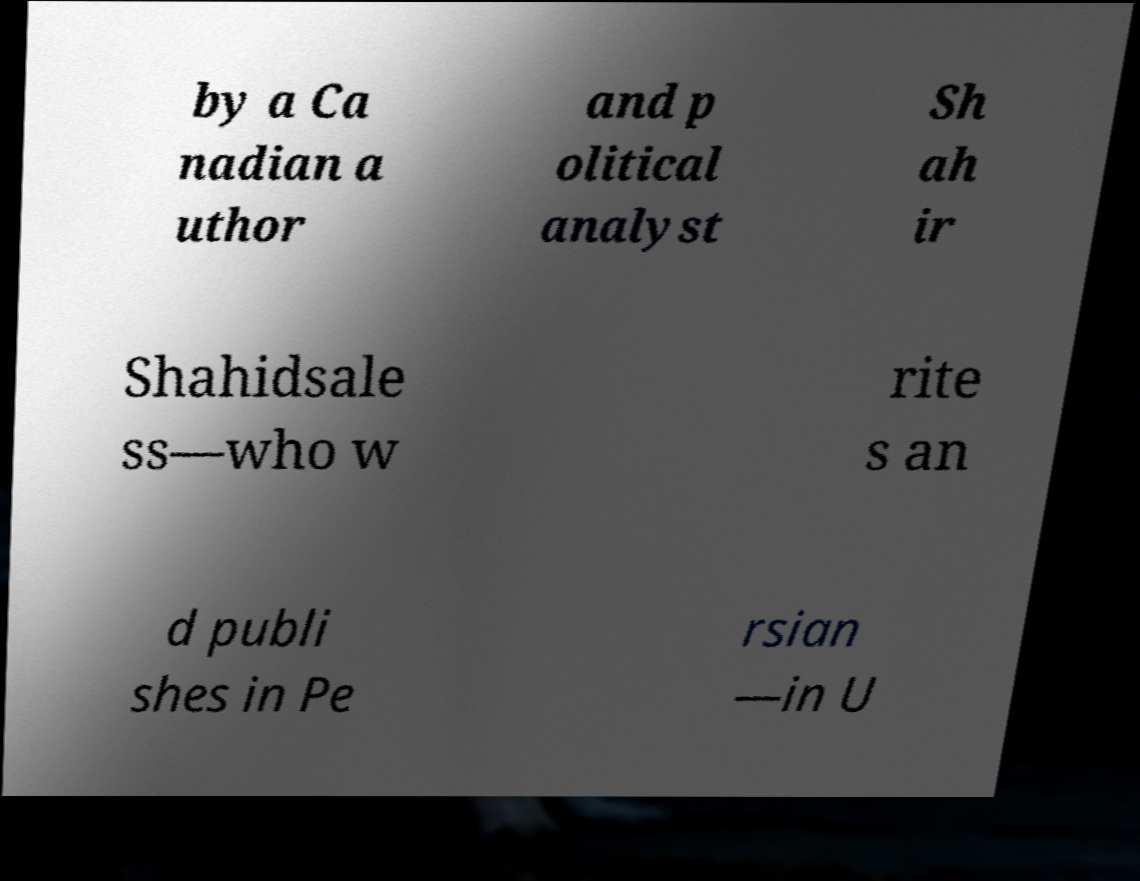I need the written content from this picture converted into text. Can you do that? by a Ca nadian a uthor and p olitical analyst Sh ah ir Shahidsale ss—who w rite s an d publi shes in Pe rsian —in U 